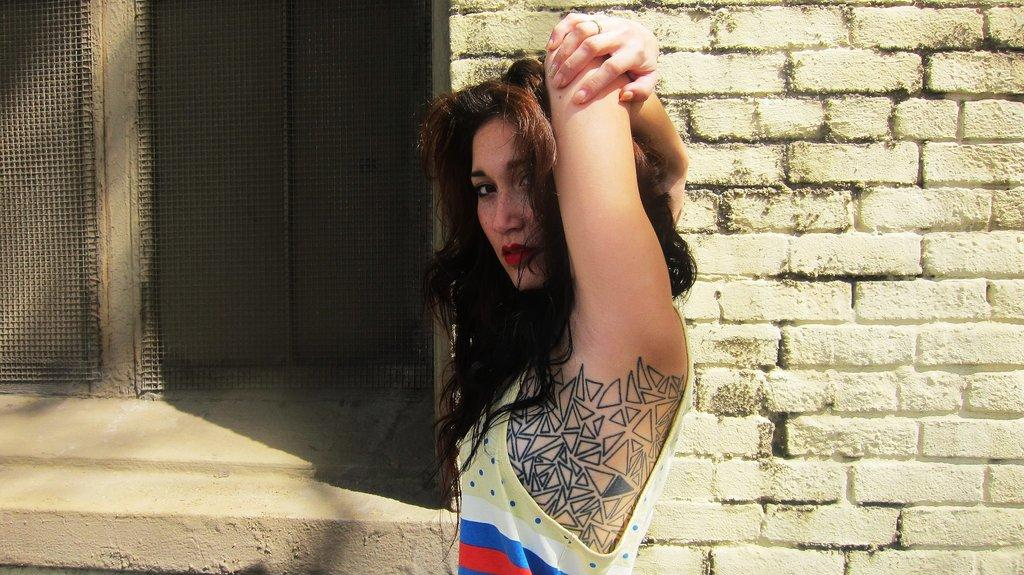What is the main subject of the image? There is a person standing in the center of the image. What is the person wearing? The person is wearing a different costume. What can be seen in the background of the image? There is a brick wall and a window in the background of the image. What song is the person singing in the image? There is no indication in the image that the person is singing, so it cannot be determined from the picture. 